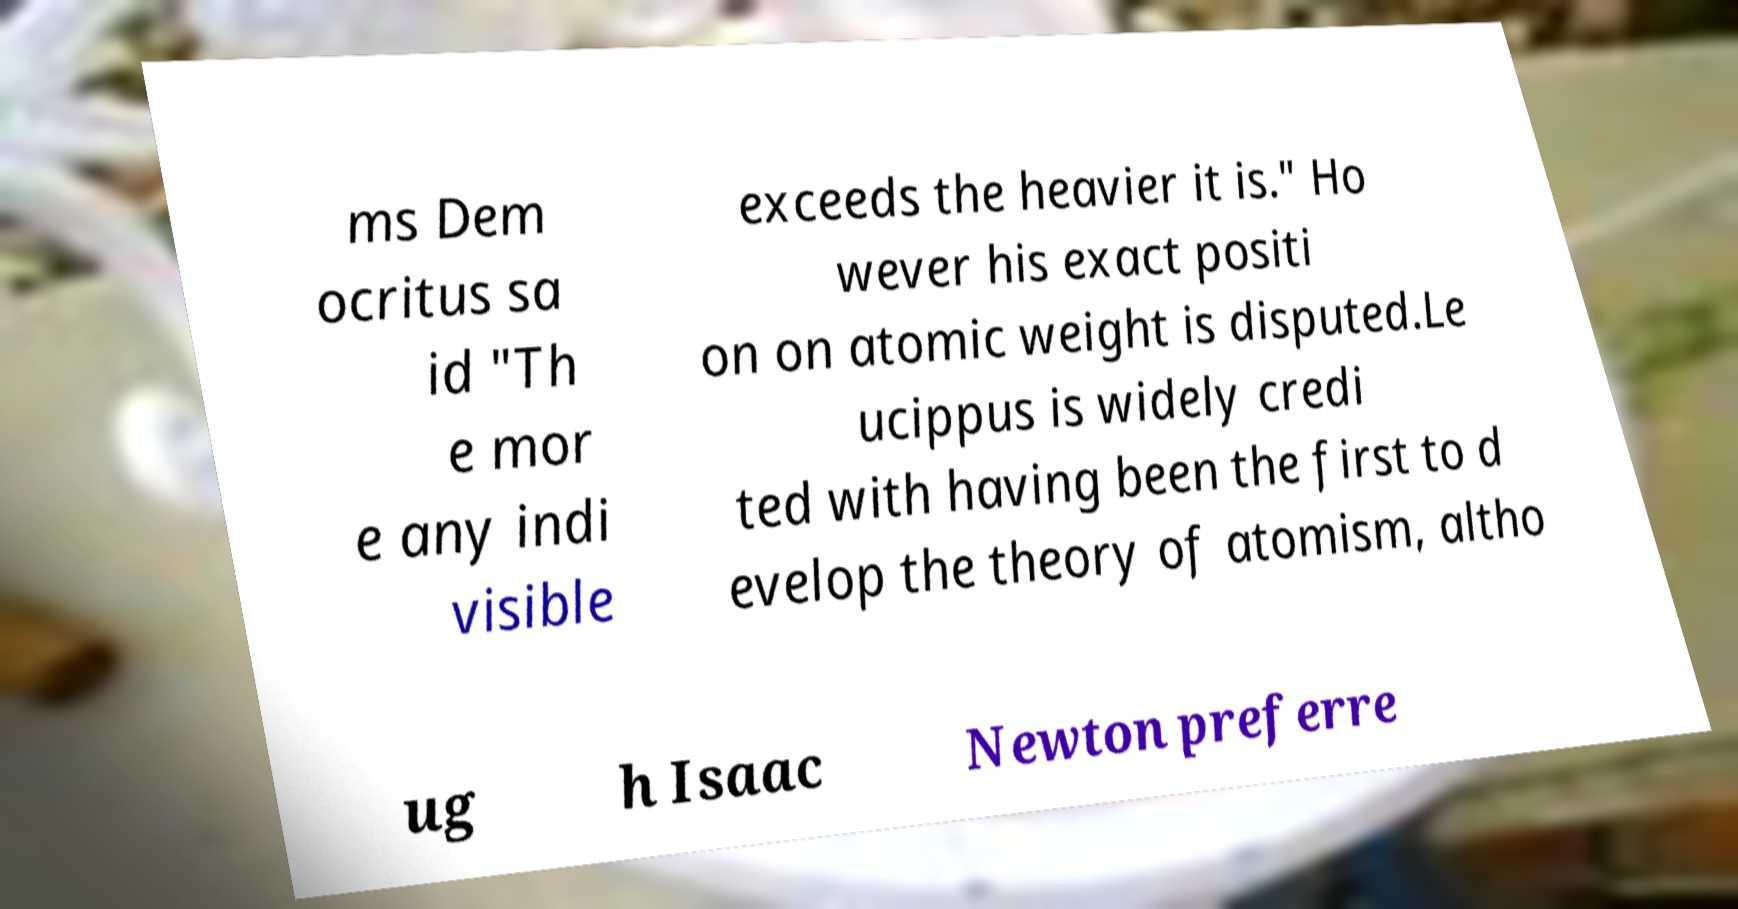Please read and relay the text visible in this image. What does it say? ms Dem ocritus sa id "Th e mor e any indi visible exceeds the heavier it is." Ho wever his exact positi on on atomic weight is disputed.Le ucippus is widely credi ted with having been the first to d evelop the theory of atomism, altho ug h Isaac Newton preferre 